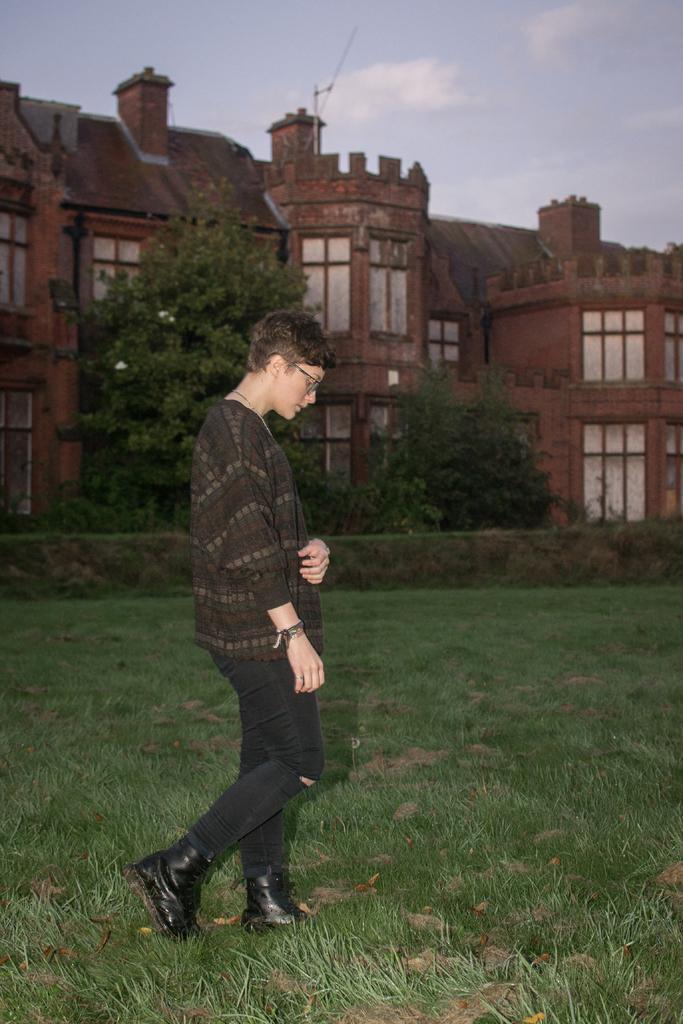In one or two sentences, can you explain what this image depicts? In the center of the image, we can see a person wearing glasses and walking and in the background, there are trees and we can see a building. At the bottom, there is ground covered with grass. 